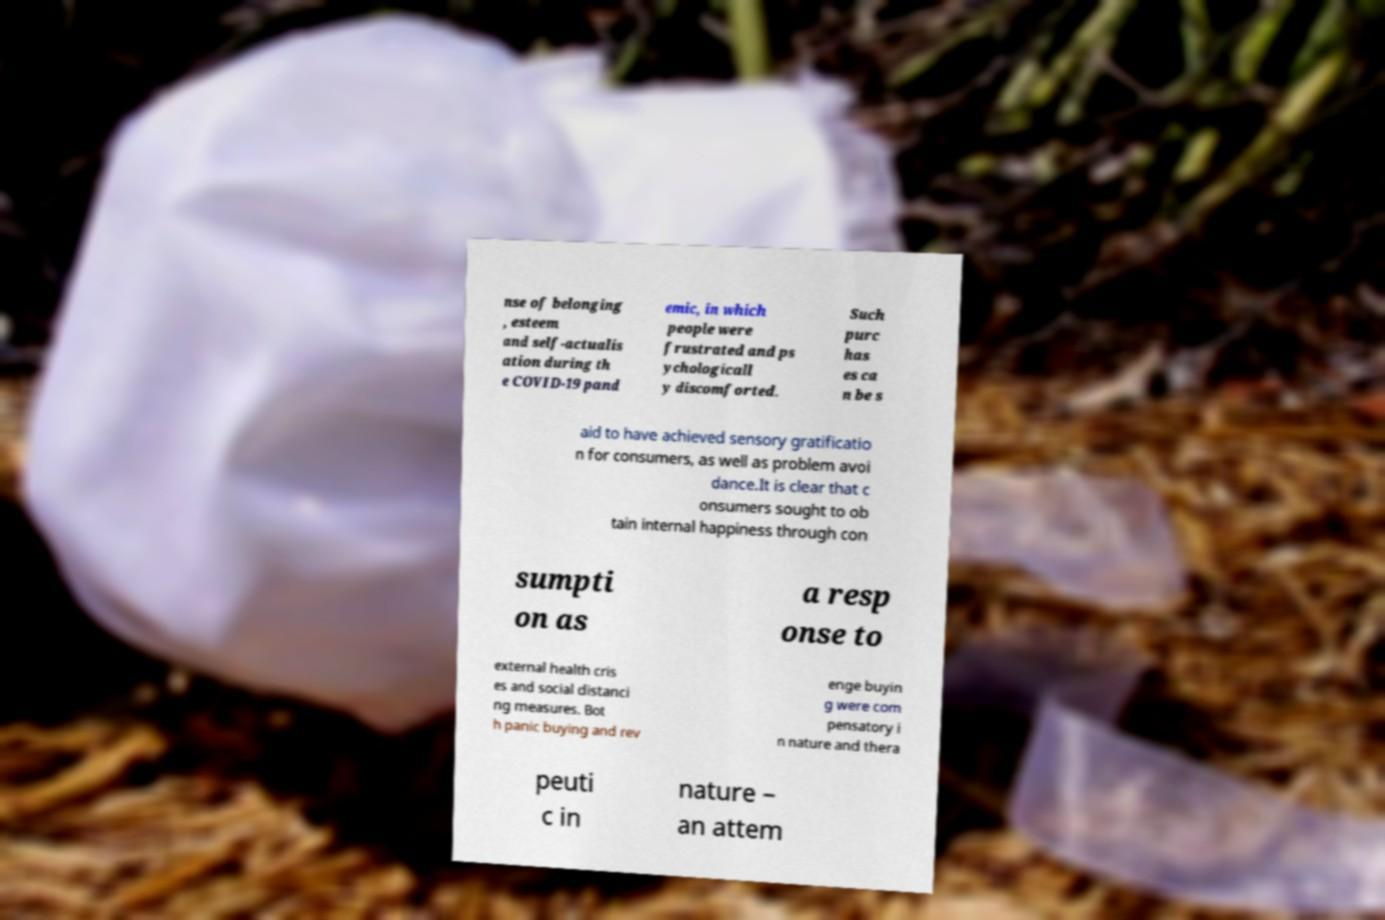There's text embedded in this image that I need extracted. Can you transcribe it verbatim? nse of belonging , esteem and self-actualis ation during th e COVID-19 pand emic, in which people were frustrated and ps ychologicall y discomforted. Such purc has es ca n be s aid to have achieved sensory gratificatio n for consumers, as well as problem avoi dance.It is clear that c onsumers sought to ob tain internal happiness through con sumpti on as a resp onse to external health cris es and social distanci ng measures. Bot h panic buying and rev enge buyin g were com pensatory i n nature and thera peuti c in nature – an attem 